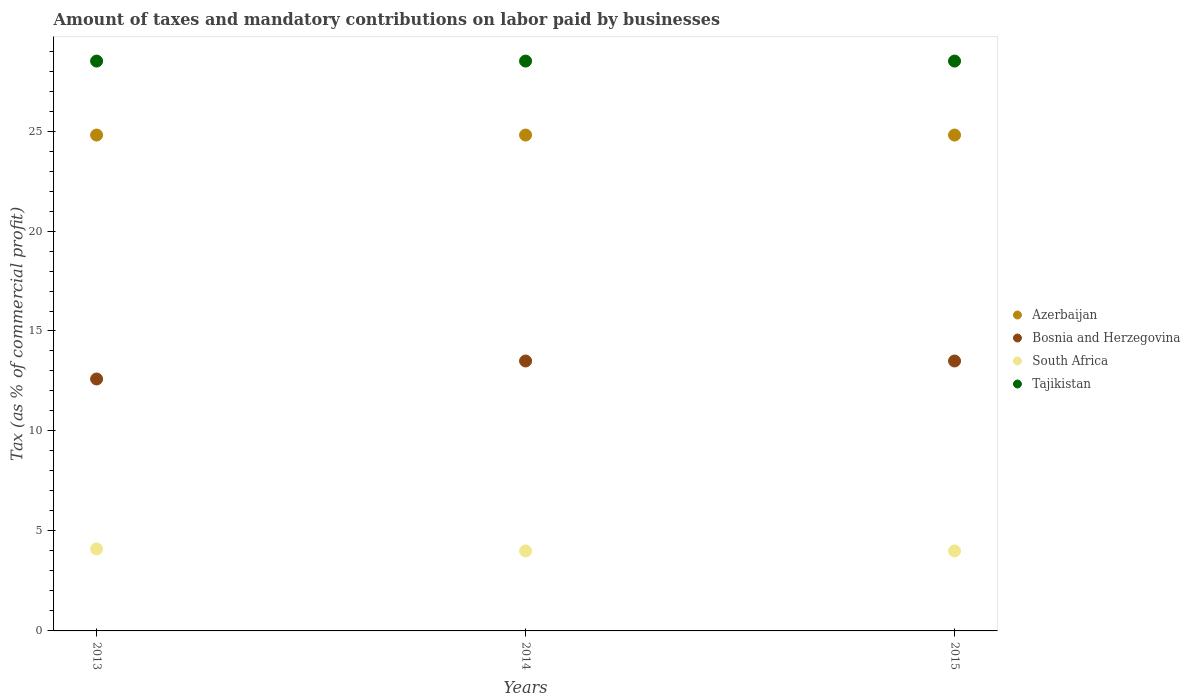How many different coloured dotlines are there?
Make the answer very short. 4. Is the number of dotlines equal to the number of legend labels?
Your answer should be very brief. Yes. Across all years, what is the maximum percentage of taxes paid by businesses in Tajikistan?
Ensure brevity in your answer.  28.5. Across all years, what is the minimum percentage of taxes paid by businesses in Azerbaijan?
Offer a very short reply. 24.8. In which year was the percentage of taxes paid by businesses in Tajikistan minimum?
Give a very brief answer. 2013. What is the total percentage of taxes paid by businesses in Azerbaijan in the graph?
Your answer should be very brief. 74.4. What is the difference between the percentage of taxes paid by businesses in Bosnia and Herzegovina in 2013 and that in 2015?
Keep it short and to the point. -0.9. What is the difference between the percentage of taxes paid by businesses in Bosnia and Herzegovina in 2015 and the percentage of taxes paid by businesses in Azerbaijan in 2013?
Offer a very short reply. -11.3. What is the average percentage of taxes paid by businesses in South Africa per year?
Provide a succinct answer. 4.03. In the year 2013, what is the difference between the percentage of taxes paid by businesses in South Africa and percentage of taxes paid by businesses in Azerbaijan?
Offer a very short reply. -20.7. What is the ratio of the percentage of taxes paid by businesses in South Africa in 2014 to that in 2015?
Offer a very short reply. 1. What is the difference between the highest and the lowest percentage of taxes paid by businesses in Azerbaijan?
Provide a short and direct response. 0. Is the sum of the percentage of taxes paid by businesses in South Africa in 2014 and 2015 greater than the maximum percentage of taxes paid by businesses in Bosnia and Herzegovina across all years?
Offer a very short reply. No. Is it the case that in every year, the sum of the percentage of taxes paid by businesses in South Africa and percentage of taxes paid by businesses in Tajikistan  is greater than the percentage of taxes paid by businesses in Bosnia and Herzegovina?
Your response must be concise. Yes. Is the percentage of taxes paid by businesses in Tajikistan strictly less than the percentage of taxes paid by businesses in Bosnia and Herzegovina over the years?
Your answer should be very brief. No. How many dotlines are there?
Ensure brevity in your answer.  4. How many years are there in the graph?
Ensure brevity in your answer.  3. Are the values on the major ticks of Y-axis written in scientific E-notation?
Your response must be concise. No. Does the graph contain grids?
Offer a very short reply. No. What is the title of the graph?
Your response must be concise. Amount of taxes and mandatory contributions on labor paid by businesses. Does "South Africa" appear as one of the legend labels in the graph?
Give a very brief answer. Yes. What is the label or title of the X-axis?
Ensure brevity in your answer.  Years. What is the label or title of the Y-axis?
Ensure brevity in your answer.  Tax (as % of commercial profit). What is the Tax (as % of commercial profit) of Azerbaijan in 2013?
Your answer should be very brief. 24.8. What is the Tax (as % of commercial profit) of Bosnia and Herzegovina in 2013?
Your answer should be very brief. 12.6. What is the Tax (as % of commercial profit) of Azerbaijan in 2014?
Your response must be concise. 24.8. What is the Tax (as % of commercial profit) of Azerbaijan in 2015?
Ensure brevity in your answer.  24.8. What is the Tax (as % of commercial profit) of Bosnia and Herzegovina in 2015?
Keep it short and to the point. 13.5. What is the Tax (as % of commercial profit) of Tajikistan in 2015?
Keep it short and to the point. 28.5. Across all years, what is the maximum Tax (as % of commercial profit) in Azerbaijan?
Offer a terse response. 24.8. Across all years, what is the maximum Tax (as % of commercial profit) in Bosnia and Herzegovina?
Your response must be concise. 13.5. Across all years, what is the maximum Tax (as % of commercial profit) of South Africa?
Offer a terse response. 4.1. Across all years, what is the minimum Tax (as % of commercial profit) of Azerbaijan?
Your response must be concise. 24.8. Across all years, what is the minimum Tax (as % of commercial profit) of South Africa?
Keep it short and to the point. 4. Across all years, what is the minimum Tax (as % of commercial profit) of Tajikistan?
Offer a very short reply. 28.5. What is the total Tax (as % of commercial profit) in Azerbaijan in the graph?
Your answer should be very brief. 74.4. What is the total Tax (as % of commercial profit) of Bosnia and Herzegovina in the graph?
Give a very brief answer. 39.6. What is the total Tax (as % of commercial profit) of Tajikistan in the graph?
Your answer should be compact. 85.5. What is the difference between the Tax (as % of commercial profit) of Azerbaijan in 2013 and that in 2014?
Your response must be concise. 0. What is the difference between the Tax (as % of commercial profit) in Bosnia and Herzegovina in 2013 and that in 2014?
Ensure brevity in your answer.  -0.9. What is the difference between the Tax (as % of commercial profit) of South Africa in 2013 and that in 2014?
Offer a very short reply. 0.1. What is the difference between the Tax (as % of commercial profit) of Bosnia and Herzegovina in 2013 and that in 2015?
Provide a short and direct response. -0.9. What is the difference between the Tax (as % of commercial profit) of Azerbaijan in 2014 and that in 2015?
Provide a short and direct response. 0. What is the difference between the Tax (as % of commercial profit) in Azerbaijan in 2013 and the Tax (as % of commercial profit) in Bosnia and Herzegovina in 2014?
Provide a short and direct response. 11.3. What is the difference between the Tax (as % of commercial profit) in Azerbaijan in 2013 and the Tax (as % of commercial profit) in South Africa in 2014?
Your answer should be compact. 20.8. What is the difference between the Tax (as % of commercial profit) of Azerbaijan in 2013 and the Tax (as % of commercial profit) of Tajikistan in 2014?
Your answer should be compact. -3.7. What is the difference between the Tax (as % of commercial profit) in Bosnia and Herzegovina in 2013 and the Tax (as % of commercial profit) in South Africa in 2014?
Ensure brevity in your answer.  8.6. What is the difference between the Tax (as % of commercial profit) in Bosnia and Herzegovina in 2013 and the Tax (as % of commercial profit) in Tajikistan in 2014?
Your answer should be compact. -15.9. What is the difference between the Tax (as % of commercial profit) of South Africa in 2013 and the Tax (as % of commercial profit) of Tajikistan in 2014?
Provide a short and direct response. -24.4. What is the difference between the Tax (as % of commercial profit) of Azerbaijan in 2013 and the Tax (as % of commercial profit) of Bosnia and Herzegovina in 2015?
Your answer should be very brief. 11.3. What is the difference between the Tax (as % of commercial profit) in Azerbaijan in 2013 and the Tax (as % of commercial profit) in South Africa in 2015?
Offer a very short reply. 20.8. What is the difference between the Tax (as % of commercial profit) in Azerbaijan in 2013 and the Tax (as % of commercial profit) in Tajikistan in 2015?
Make the answer very short. -3.7. What is the difference between the Tax (as % of commercial profit) of Bosnia and Herzegovina in 2013 and the Tax (as % of commercial profit) of South Africa in 2015?
Provide a succinct answer. 8.6. What is the difference between the Tax (as % of commercial profit) in Bosnia and Herzegovina in 2013 and the Tax (as % of commercial profit) in Tajikistan in 2015?
Offer a very short reply. -15.9. What is the difference between the Tax (as % of commercial profit) of South Africa in 2013 and the Tax (as % of commercial profit) of Tajikistan in 2015?
Provide a short and direct response. -24.4. What is the difference between the Tax (as % of commercial profit) of Azerbaijan in 2014 and the Tax (as % of commercial profit) of South Africa in 2015?
Your answer should be compact. 20.8. What is the difference between the Tax (as % of commercial profit) of Bosnia and Herzegovina in 2014 and the Tax (as % of commercial profit) of South Africa in 2015?
Offer a very short reply. 9.5. What is the difference between the Tax (as % of commercial profit) in South Africa in 2014 and the Tax (as % of commercial profit) in Tajikistan in 2015?
Provide a short and direct response. -24.5. What is the average Tax (as % of commercial profit) in Azerbaijan per year?
Your answer should be compact. 24.8. What is the average Tax (as % of commercial profit) of Bosnia and Herzegovina per year?
Make the answer very short. 13.2. What is the average Tax (as % of commercial profit) of South Africa per year?
Provide a succinct answer. 4.03. What is the average Tax (as % of commercial profit) of Tajikistan per year?
Keep it short and to the point. 28.5. In the year 2013, what is the difference between the Tax (as % of commercial profit) in Azerbaijan and Tax (as % of commercial profit) in Bosnia and Herzegovina?
Ensure brevity in your answer.  12.2. In the year 2013, what is the difference between the Tax (as % of commercial profit) of Azerbaijan and Tax (as % of commercial profit) of South Africa?
Your response must be concise. 20.7. In the year 2013, what is the difference between the Tax (as % of commercial profit) of Azerbaijan and Tax (as % of commercial profit) of Tajikistan?
Provide a short and direct response. -3.7. In the year 2013, what is the difference between the Tax (as % of commercial profit) of Bosnia and Herzegovina and Tax (as % of commercial profit) of Tajikistan?
Your response must be concise. -15.9. In the year 2013, what is the difference between the Tax (as % of commercial profit) in South Africa and Tax (as % of commercial profit) in Tajikistan?
Keep it short and to the point. -24.4. In the year 2014, what is the difference between the Tax (as % of commercial profit) of Azerbaijan and Tax (as % of commercial profit) of South Africa?
Your response must be concise. 20.8. In the year 2014, what is the difference between the Tax (as % of commercial profit) in South Africa and Tax (as % of commercial profit) in Tajikistan?
Offer a terse response. -24.5. In the year 2015, what is the difference between the Tax (as % of commercial profit) in Azerbaijan and Tax (as % of commercial profit) in South Africa?
Your answer should be compact. 20.8. In the year 2015, what is the difference between the Tax (as % of commercial profit) of Bosnia and Herzegovina and Tax (as % of commercial profit) of South Africa?
Keep it short and to the point. 9.5. In the year 2015, what is the difference between the Tax (as % of commercial profit) of South Africa and Tax (as % of commercial profit) of Tajikistan?
Provide a succinct answer. -24.5. What is the ratio of the Tax (as % of commercial profit) in Azerbaijan in 2013 to that in 2014?
Provide a succinct answer. 1. What is the ratio of the Tax (as % of commercial profit) of Bosnia and Herzegovina in 2013 to that in 2014?
Make the answer very short. 0.93. What is the ratio of the Tax (as % of commercial profit) of South Africa in 2013 to that in 2014?
Keep it short and to the point. 1.02. What is the ratio of the Tax (as % of commercial profit) in Tajikistan in 2013 to that in 2014?
Your response must be concise. 1. What is the ratio of the Tax (as % of commercial profit) in Bosnia and Herzegovina in 2013 to that in 2015?
Offer a terse response. 0.93. What is the ratio of the Tax (as % of commercial profit) in South Africa in 2013 to that in 2015?
Offer a very short reply. 1.02. What is the ratio of the Tax (as % of commercial profit) in Tajikistan in 2013 to that in 2015?
Offer a terse response. 1. What is the ratio of the Tax (as % of commercial profit) in Bosnia and Herzegovina in 2014 to that in 2015?
Provide a short and direct response. 1. What is the ratio of the Tax (as % of commercial profit) in South Africa in 2014 to that in 2015?
Keep it short and to the point. 1. What is the ratio of the Tax (as % of commercial profit) in Tajikistan in 2014 to that in 2015?
Offer a very short reply. 1. What is the difference between the highest and the second highest Tax (as % of commercial profit) of Bosnia and Herzegovina?
Ensure brevity in your answer.  0. What is the difference between the highest and the lowest Tax (as % of commercial profit) of Azerbaijan?
Make the answer very short. 0. What is the difference between the highest and the lowest Tax (as % of commercial profit) of South Africa?
Give a very brief answer. 0.1. What is the difference between the highest and the lowest Tax (as % of commercial profit) of Tajikistan?
Provide a short and direct response. 0. 